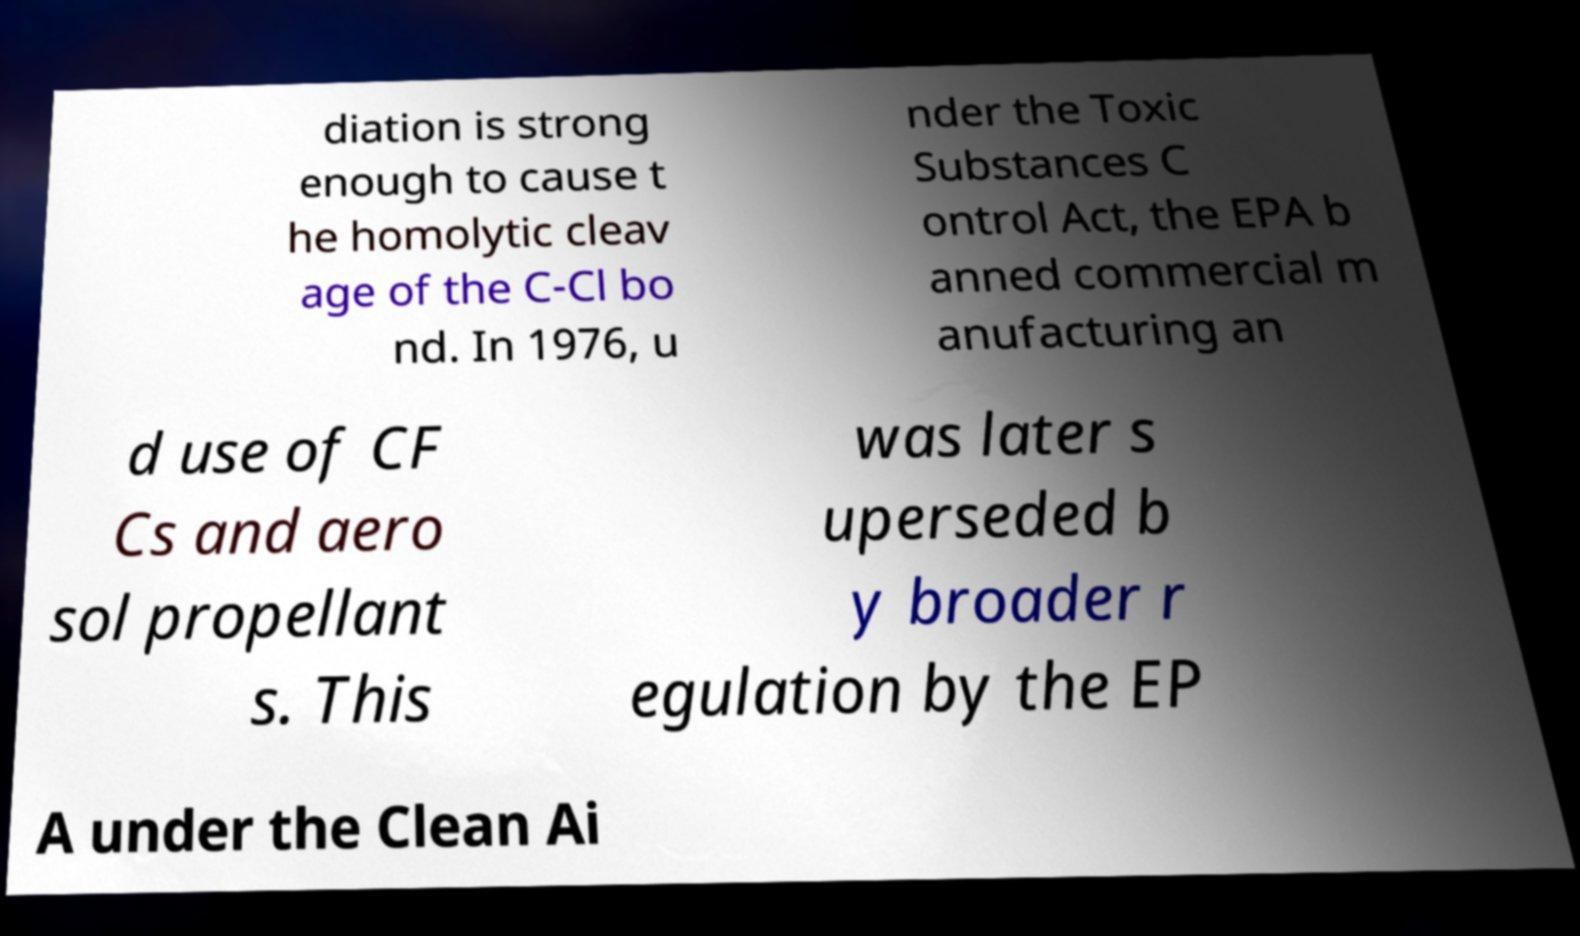I need the written content from this picture converted into text. Can you do that? diation is strong enough to cause t he homolytic cleav age of the C-Cl bo nd. In 1976, u nder the Toxic Substances C ontrol Act, the EPA b anned commercial m anufacturing an d use of CF Cs and aero sol propellant s. This was later s uperseded b y broader r egulation by the EP A under the Clean Ai 